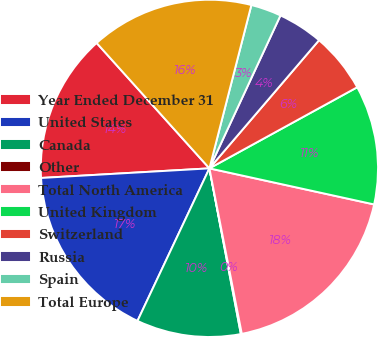<chart> <loc_0><loc_0><loc_500><loc_500><pie_chart><fcel>Year Ended December 31<fcel>United States<fcel>Canada<fcel>Other<fcel>Total North America<fcel>United Kingdom<fcel>Switzerland<fcel>Russia<fcel>Spain<fcel>Total Europe<nl><fcel>14.25%<fcel>17.08%<fcel>10.0%<fcel>0.09%<fcel>18.49%<fcel>11.42%<fcel>5.75%<fcel>4.34%<fcel>2.92%<fcel>15.66%<nl></chart> 